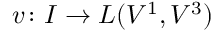Convert formula to latex. <formula><loc_0><loc_0><loc_500><loc_500>v \colon I \to L ( V ^ { 1 } , V ^ { 3 } )</formula> 